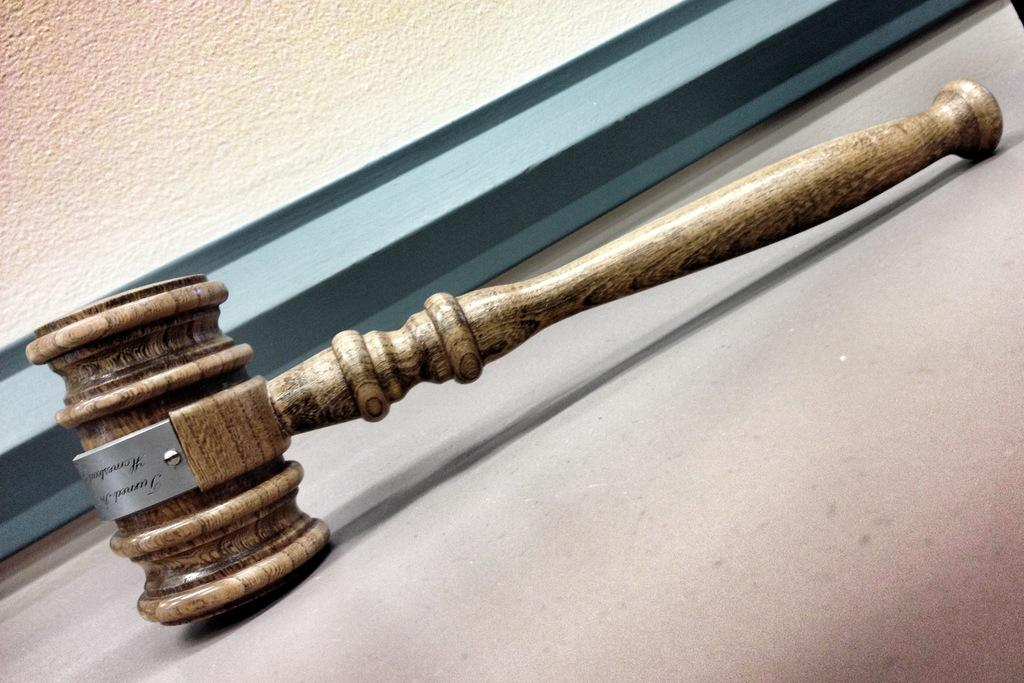What object is the main subject of the picture? The main subject of the picture is a wooden hammer. What material is the hammer made of? The wooden hammer is made of wood. Are there any words or text on the hammer? Yes, there is some text on the wooden hammer. What can be seen in the background of the picture? There is a wall in the background of the picture. What type of jeans is the person wearing in the image? There is no person or jeans present in the image; it features a wooden hammer with text on it and a wall in the background. 